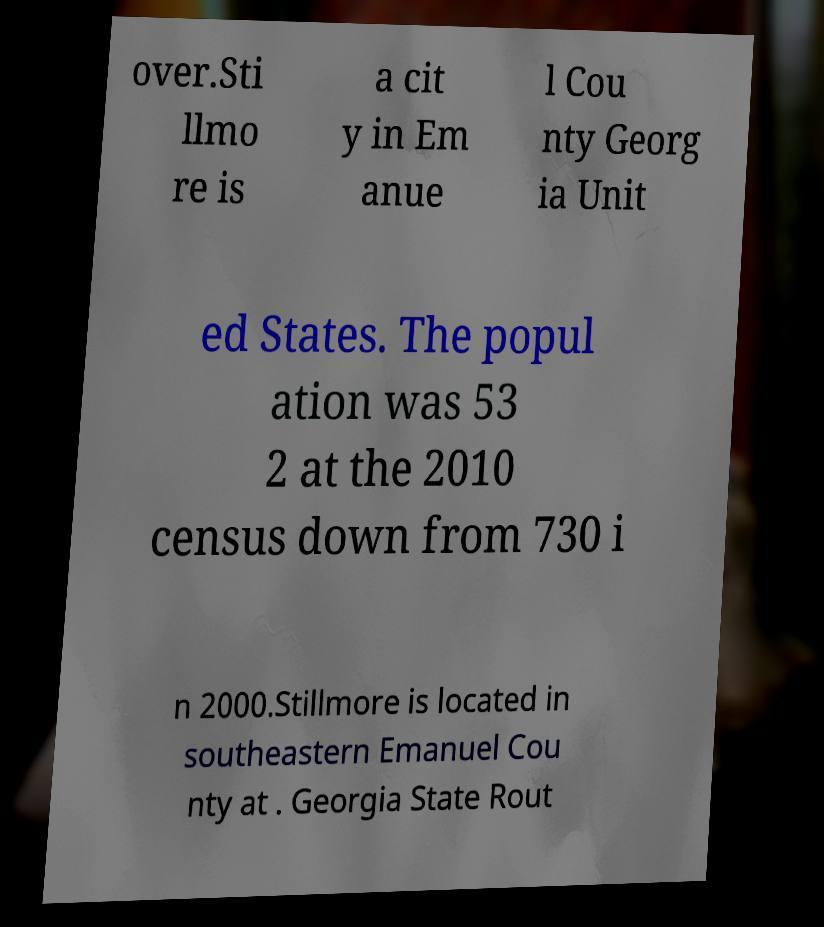Please read and relay the text visible in this image. What does it say? over.Sti llmo re is a cit y in Em anue l Cou nty Georg ia Unit ed States. The popul ation was 53 2 at the 2010 census down from 730 i n 2000.Stillmore is located in southeastern Emanuel Cou nty at . Georgia State Rout 